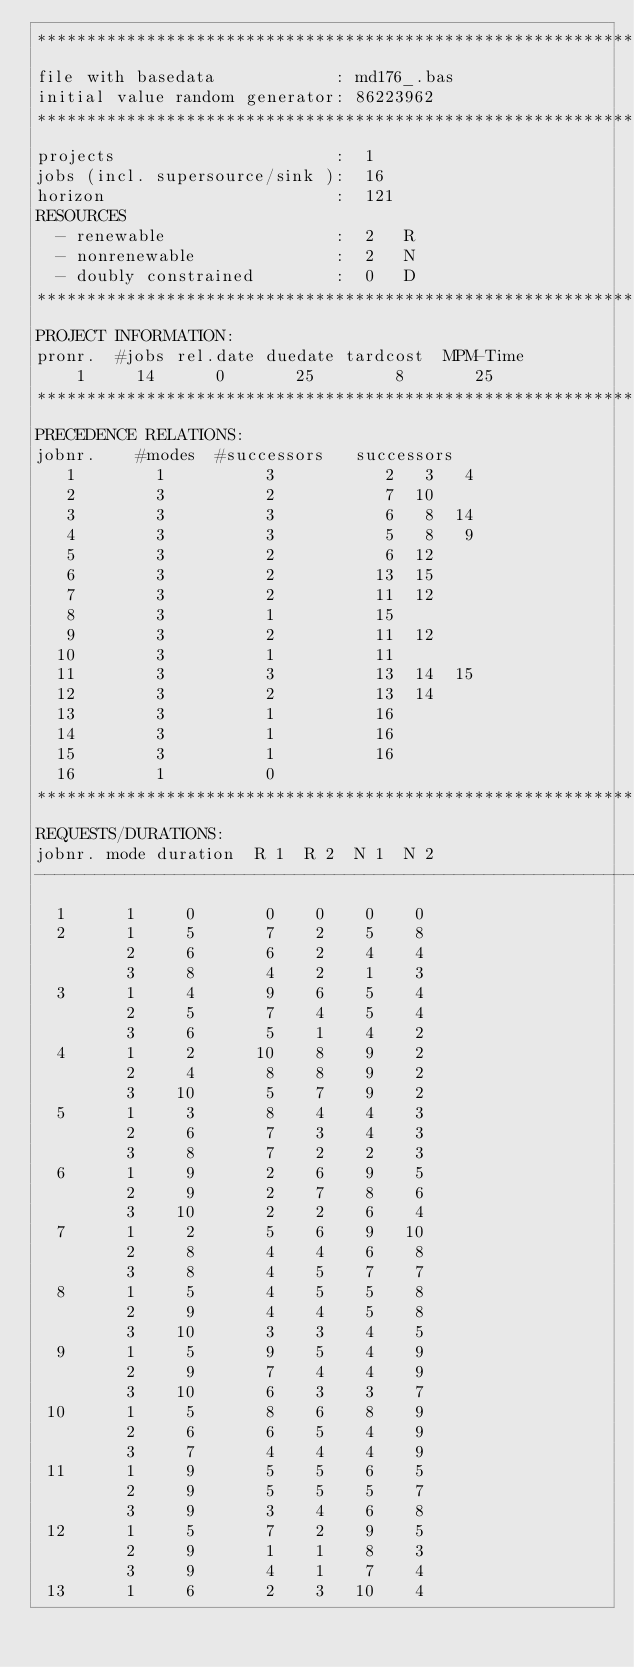Convert code to text. <code><loc_0><loc_0><loc_500><loc_500><_ObjectiveC_>************************************************************************
file with basedata            : md176_.bas
initial value random generator: 86223962
************************************************************************
projects                      :  1
jobs (incl. supersource/sink ):  16
horizon                       :  121
RESOURCES
  - renewable                 :  2   R
  - nonrenewable              :  2   N
  - doubly constrained        :  0   D
************************************************************************
PROJECT INFORMATION:
pronr.  #jobs rel.date duedate tardcost  MPM-Time
    1     14      0       25        8       25
************************************************************************
PRECEDENCE RELATIONS:
jobnr.    #modes  #successors   successors
   1        1          3           2   3   4
   2        3          2           7  10
   3        3          3           6   8  14
   4        3          3           5   8   9
   5        3          2           6  12
   6        3          2          13  15
   7        3          2          11  12
   8        3          1          15
   9        3          2          11  12
  10        3          1          11
  11        3          3          13  14  15
  12        3          2          13  14
  13        3          1          16
  14        3          1          16
  15        3          1          16
  16        1          0        
************************************************************************
REQUESTS/DURATIONS:
jobnr. mode duration  R 1  R 2  N 1  N 2
------------------------------------------------------------------------
  1      1     0       0    0    0    0
  2      1     5       7    2    5    8
         2     6       6    2    4    4
         3     8       4    2    1    3
  3      1     4       9    6    5    4
         2     5       7    4    5    4
         3     6       5    1    4    2
  4      1     2      10    8    9    2
         2     4       8    8    9    2
         3    10       5    7    9    2
  5      1     3       8    4    4    3
         2     6       7    3    4    3
         3     8       7    2    2    3
  6      1     9       2    6    9    5
         2     9       2    7    8    6
         3    10       2    2    6    4
  7      1     2       5    6    9   10
         2     8       4    4    6    8
         3     8       4    5    7    7
  8      1     5       4    5    5    8
         2     9       4    4    5    8
         3    10       3    3    4    5
  9      1     5       9    5    4    9
         2     9       7    4    4    9
         3    10       6    3    3    7
 10      1     5       8    6    8    9
         2     6       6    5    4    9
         3     7       4    4    4    9
 11      1     9       5    5    6    5
         2     9       5    5    5    7
         3     9       3    4    6    8
 12      1     5       7    2    9    5
         2     9       1    1    8    3
         3     9       4    1    7    4
 13      1     6       2    3   10    4</code> 